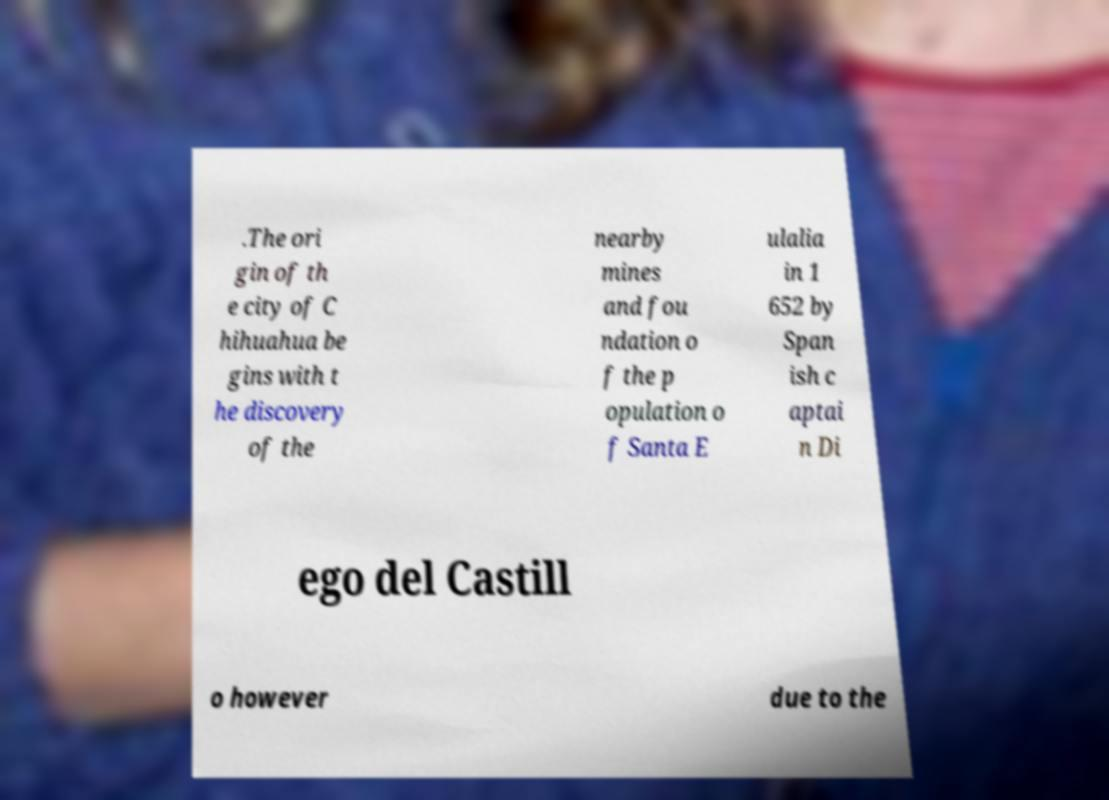Please identify and transcribe the text found in this image. .The ori gin of th e city of C hihuahua be gins with t he discovery of the nearby mines and fou ndation o f the p opulation o f Santa E ulalia in 1 652 by Span ish c aptai n Di ego del Castill o however due to the 